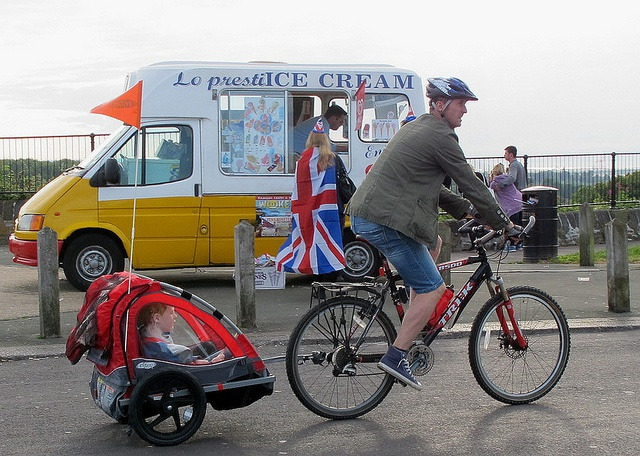Describe the objects in this image and their specific colors. I can see truck in white, darkgray, olive, and lightgray tones, bicycle in white, black, gray, darkgray, and maroon tones, people in white, gray, black, and navy tones, people in white, gray, navy, and black tones, and people in white, gray, and black tones in this image. 